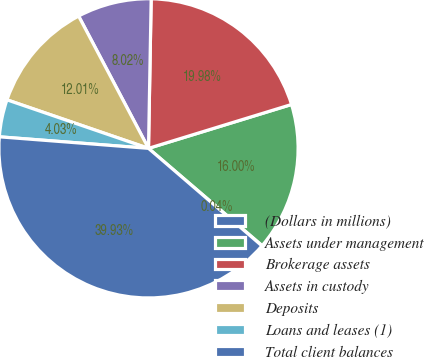Convert chart to OTSL. <chart><loc_0><loc_0><loc_500><loc_500><pie_chart><fcel>(Dollars in millions)<fcel>Assets under management<fcel>Brokerage assets<fcel>Assets in custody<fcel>Deposits<fcel>Loans and leases (1)<fcel>Total client balances<nl><fcel>0.04%<fcel>16.0%<fcel>19.98%<fcel>8.02%<fcel>12.01%<fcel>4.03%<fcel>39.93%<nl></chart> 